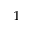Convert formula to latex. <formula><loc_0><loc_0><loc_500><loc_500>^ { 1 }</formula> 